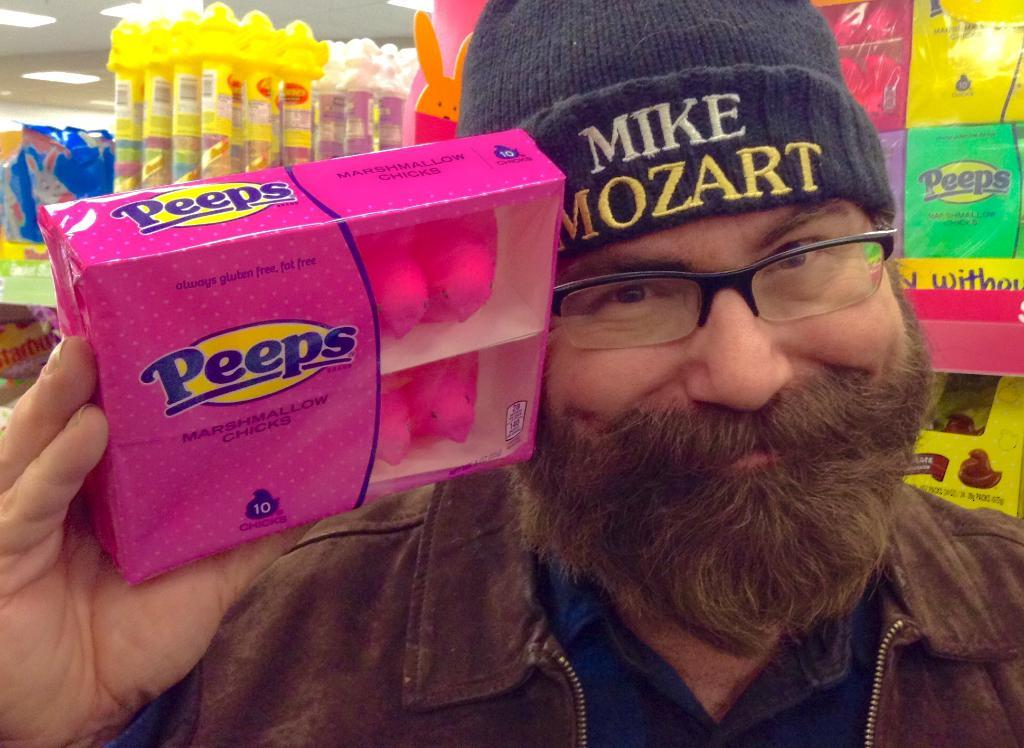What is the main subject of the image? There is a person in the image. What is the person holding in their hands? The person is holding a box in their hands. What can be seen in the background of the image? There are boxes in the racks and lights visible on top. What type of plant is growing out of the person's nose in the image? There is no plant growing out of the person's nose in the image, as the provided facts do not mention any plants or noses. 